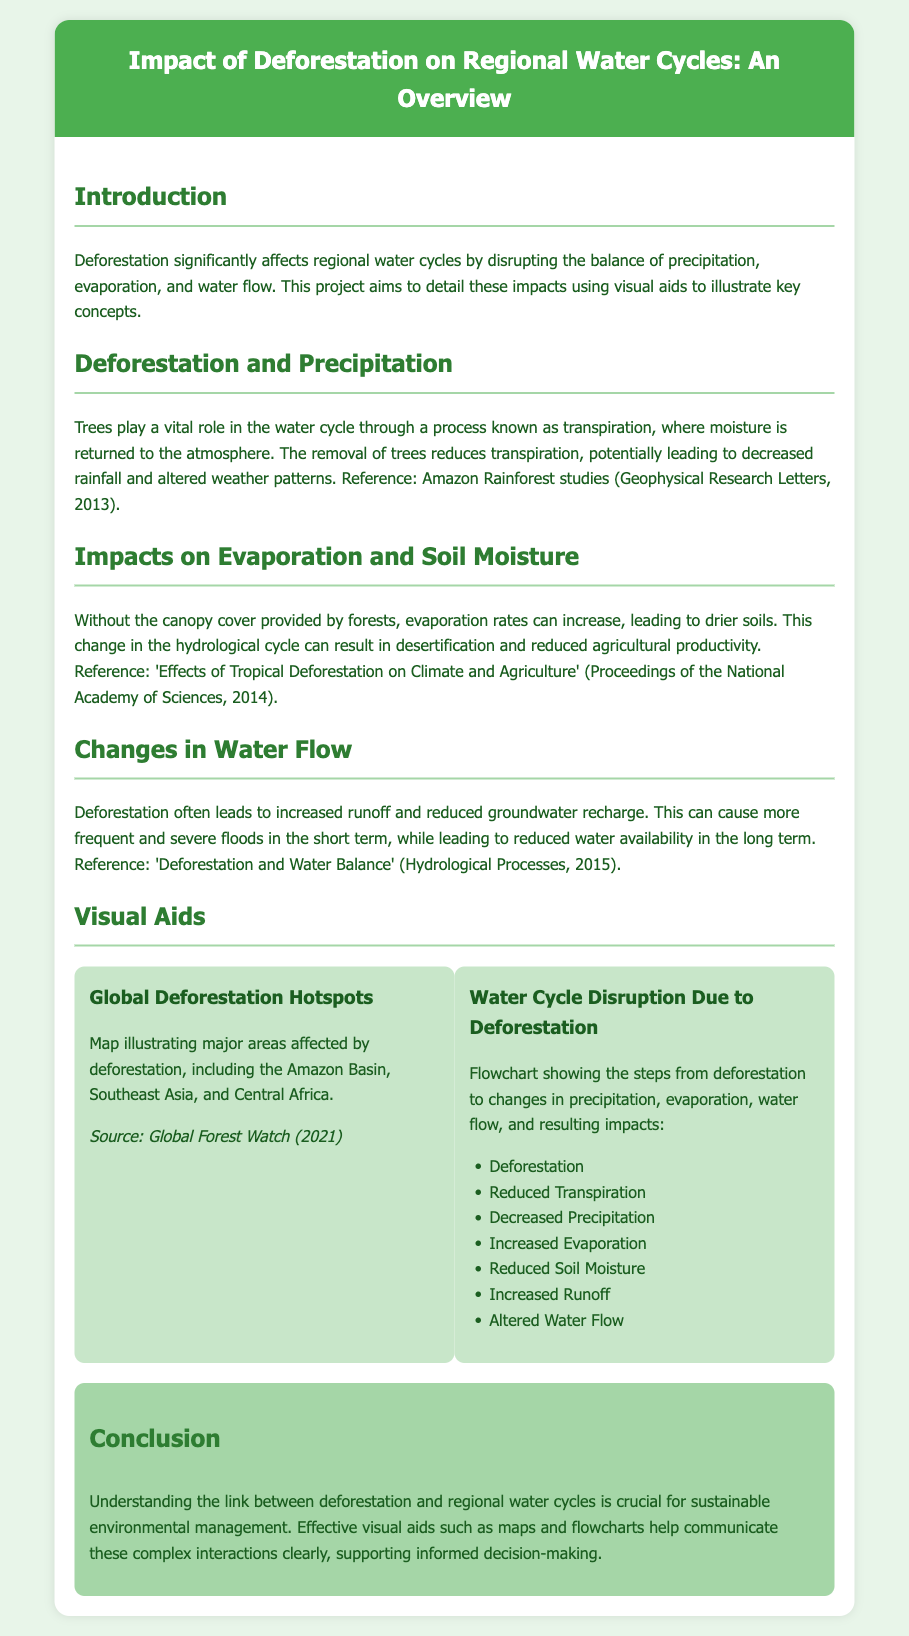what is the title of the project? The title of the project is given in the header of the document, which highlights the main focus of the research.
Answer: Impact of Deforestation on Regional Water Cycles: An Overview what is the role of trees in the water cycle? The document states that trees play a vital role through a process known as transpiration, which helps maintain moisture levels.
Answer: Transpiration what are the regions identified as deforestation hotspots? The map section discusses key areas affected by deforestation, which helps illustrate the global impact according to various studies.
Answer: Amazon Basin, Southeast Asia, Central Africa what is the first step shown in the water cycle disruption flowchart? The flowchart outlines the sequence of events that begins with deforestation and leads to various changes in the water cycle.
Answer: Deforestation which year does the Global Forest Watch source refer to? The document provides a specific year for the source of the map, indicating the data's relevance and timeliness.
Answer: 2021 how does deforestation affect soil moisture according to the document? The text discusses the consequence of losing canopy cover, directly linking it to changes in soil moisture levels.
Answer: Reduced Soil Moisture what is the main conclusion of the document? The conclusion emphasizes the importance of understanding the link between deforestation and water cycles for sustainable management.
Answer: Crucial for sustainable environmental management how many steps are listed in the flowchart? The flowchart comprises multiple steps that connect the cause (deforestation) with various effects in the water cycle.
Answer: Seven steps what color scheme is used for the header of the document? The header's color scheme is two-tone, combining a bold color with a contrasting text hue to enhance visibility.
Answer: Green and white 